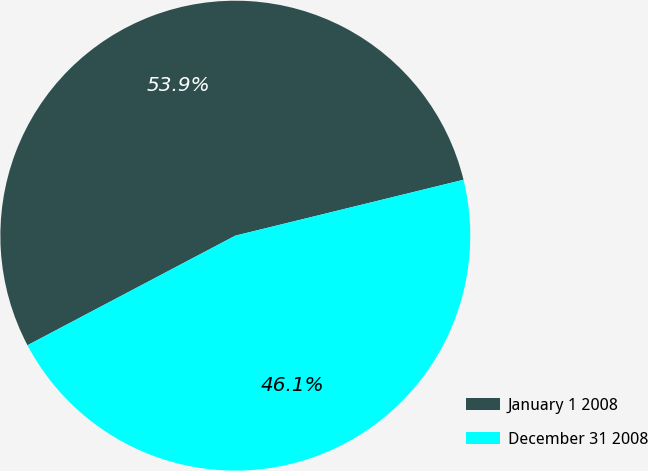Convert chart to OTSL. <chart><loc_0><loc_0><loc_500><loc_500><pie_chart><fcel>January 1 2008<fcel>December 31 2008<nl><fcel>53.9%<fcel>46.1%<nl></chart> 